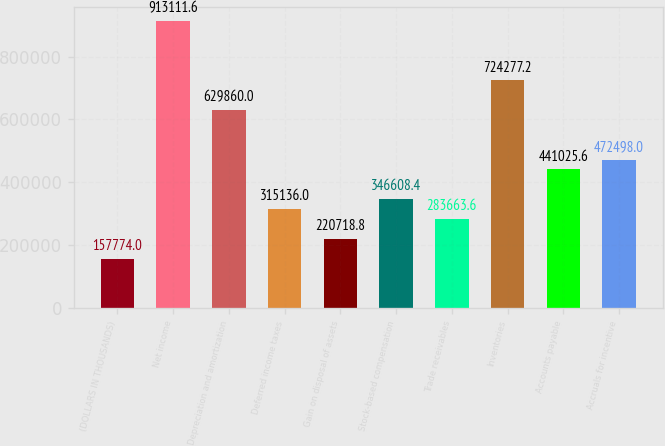Convert chart. <chart><loc_0><loc_0><loc_500><loc_500><bar_chart><fcel>(DOLLARS IN THOUSANDS)<fcel>Net income<fcel>Depreciation and amortization<fcel>Deferred income taxes<fcel>Gain on disposal of assets<fcel>Stock-based compensation<fcel>Trade receivables<fcel>Inventories<fcel>Accounts payable<fcel>Accruals for incentive<nl><fcel>157774<fcel>913112<fcel>629860<fcel>315136<fcel>220719<fcel>346608<fcel>283664<fcel>724277<fcel>441026<fcel>472498<nl></chart> 